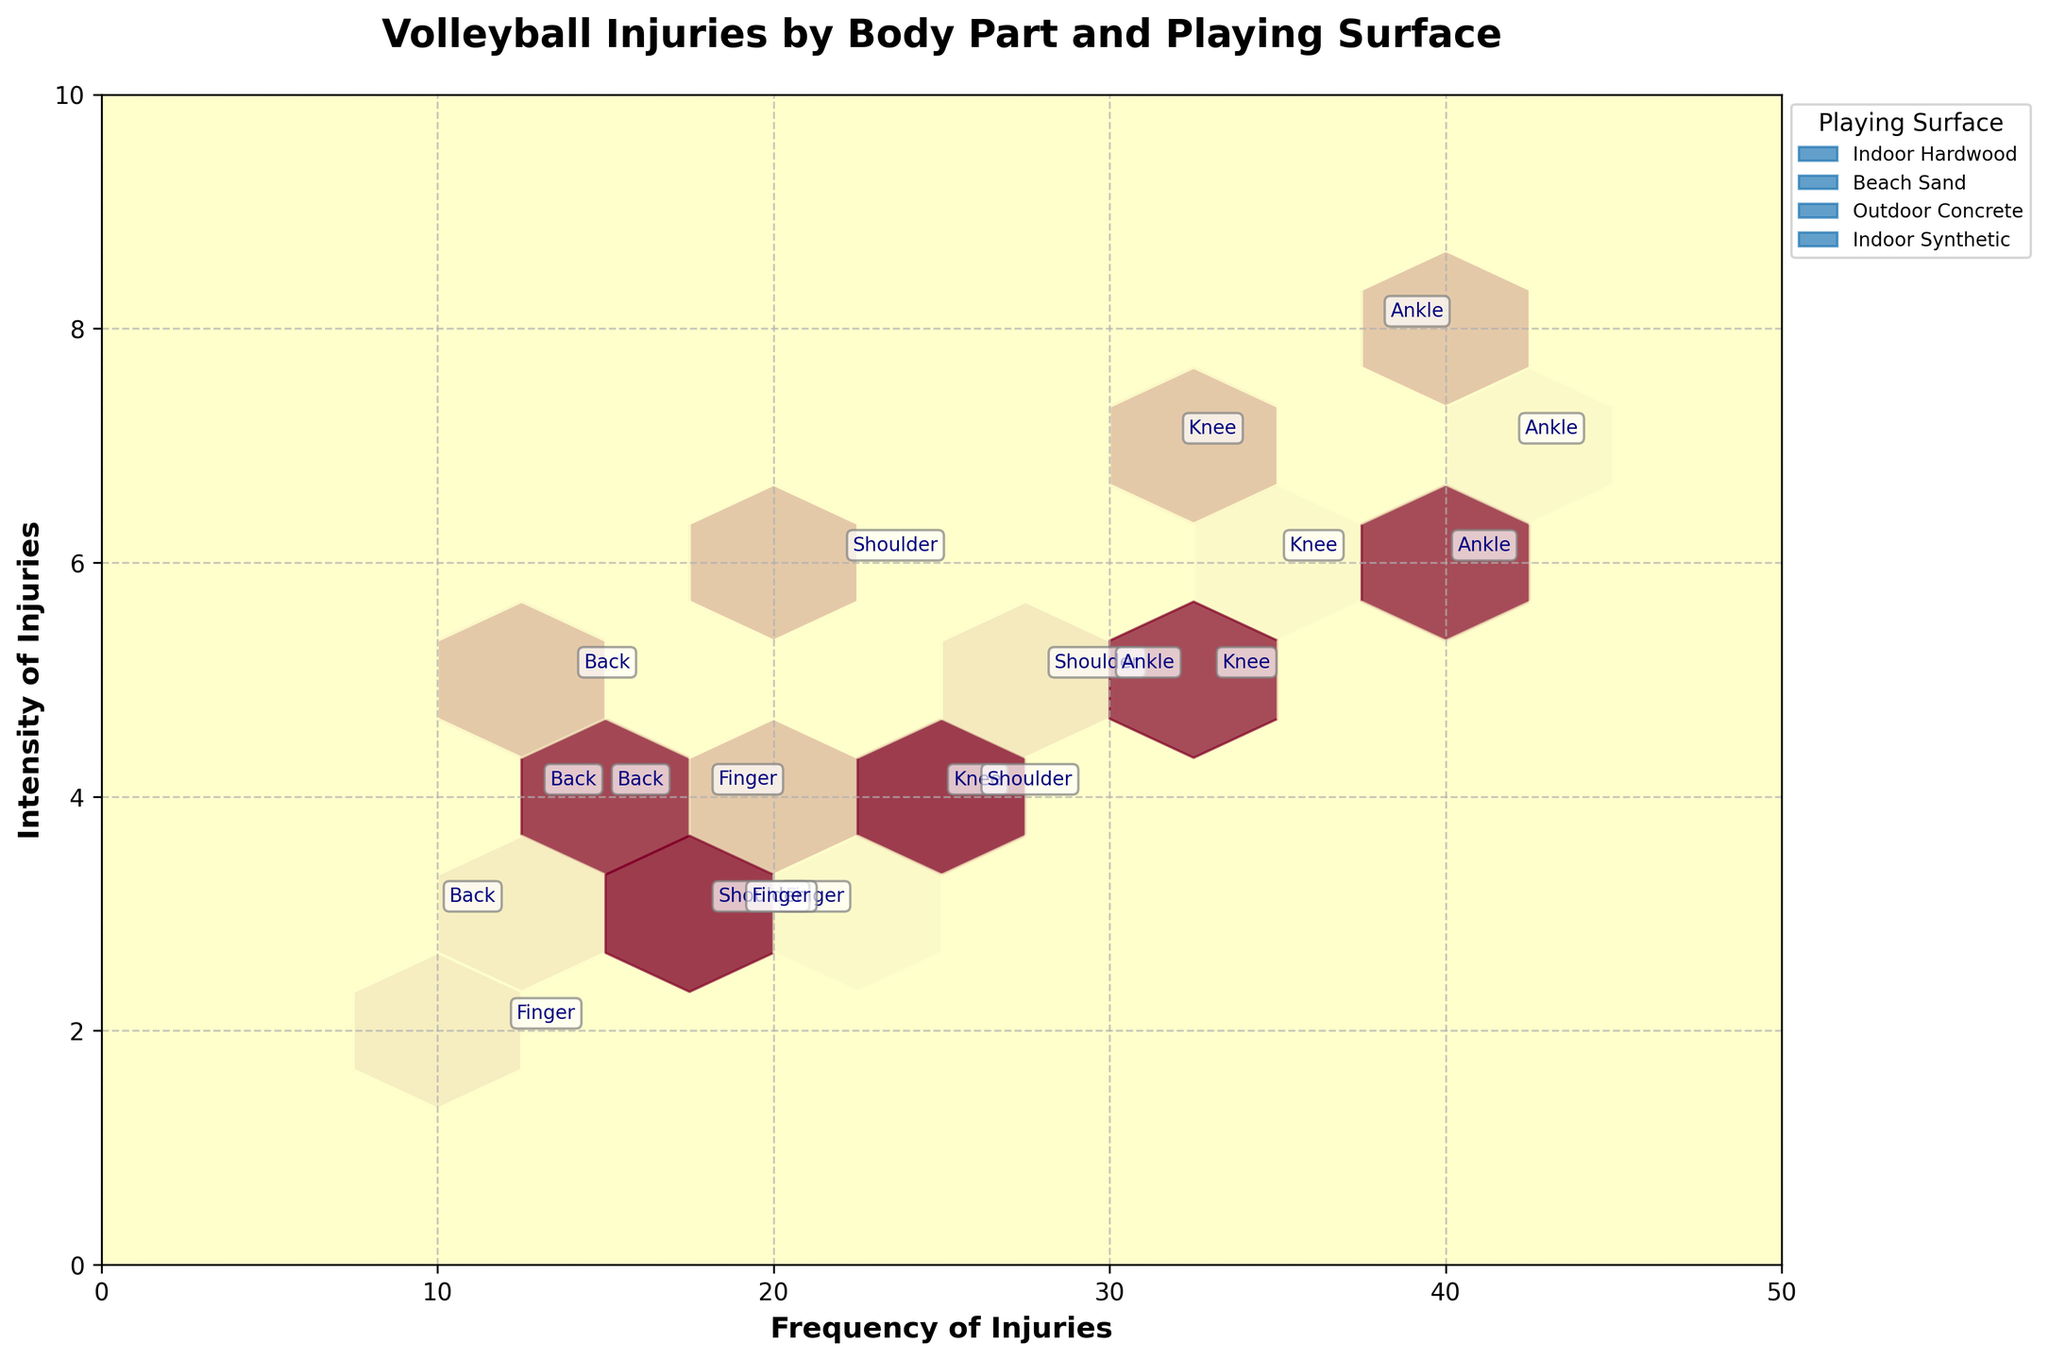What is the title of the figure? The title is typically located at the top of the figure. Reading the title helps us quickly understand the general context and what the figure is about.
Answer: Volleyball Injuries by Body Part and Playing Surface What are the x and y-axis labels? Axes labels are located at the edges of the plot area. They provide the context of what each axis is representing.
Answer: Frequency of Injuries (x-axis), Intensity of Injuries (y-axis) Which playing surface has the highest frequency of ankle injuries? By identifying different 'Playing Surface' colors, you can locate the highest frequency point on the x-axis for 'Ankle' and see which color it matches.
Answer: Indoor Hardwood For which surface do knee injuries have a higher intensity: Indoor Synthetic or Outdoor Concrete? Locate the data points for 'Knee' injuries for both 'Indoor Synthetic' and 'Outdoor Concrete' by comparing their y-axis values to see which one is higher.
Answer: Outdoor Concrete Which body part has the lowest intensity injury on Beach Sand? Find the data points for 'Beach Sand' and compare their y-axis values to identify the lowest one for 'Intensity'.
Answer: Finger What is the total frequency of shoulder injuries across all playing surfaces? Add the frequency values of 'Shoulder' injuries on all playing surfaces: Indoor Hardwood, Beach Sand, Outdoor Concrete, and Indoor Synthetic.
Answer: 94 Which injury has a higher frequency on Indoor Hardwood: knee or back? Compare the frequency values of 'Knee' and 'Back' injuries for the 'Indoor Hardwood' surface.
Answer: Knee How many distinct playing surfaces are represented in the figure? Count the unique entries in the legend representing different playing surfaces.
Answer: 4 What is the average intensity of shoulder injuries on all surfaces? Sum up intensity values for 'Shoulder' injuries across all playing surfaces and divide by the number of surfaces. (5+3+6+4)/4 = 4.5
Answer: 4.5 Which playing surface has more variation in the intensity of injuries? Compare the range of intensity (difference between highest and lowest intensity) for each playing surface.
Answer: Outdoor Concrete 